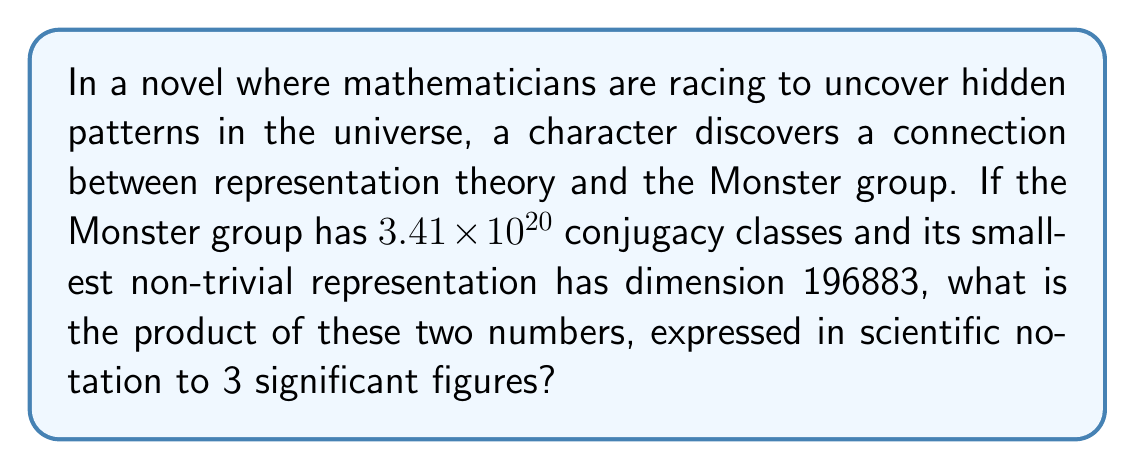Provide a solution to this math problem. To solve this problem, we'll follow these steps:

1) First, let's recall the given information:
   - The Monster group has $3.41 \times 10^{20}$ conjugacy classes
   - Its smallest non-trivial representation has dimension 196883

2) We need to multiply these two numbers:
   $$(3.41 \times 10^{20}) \times 196883$$

3) Let's break this down:
   $3.41 \times 10^{20} \times (1.96883 \times 10^5)$

4) Multiply the coefficients:
   $3.41 \times 1.96883 = 6.71371203$

5) Add the exponents:
   $10^{20} \times 10^5 = 10^{25}$

6) Combine the results:
   $6.71371203 \times 10^{25}$

7) Round to 3 significant figures:
   $6.71 \times 10^{25}$

This result beautifully illustrates the vast scale involved in the study of the Monster group, highlighting the intricate connection between representation theory and the classification of finite simple groups.
Answer: $6.71 \times 10^{25}$ 